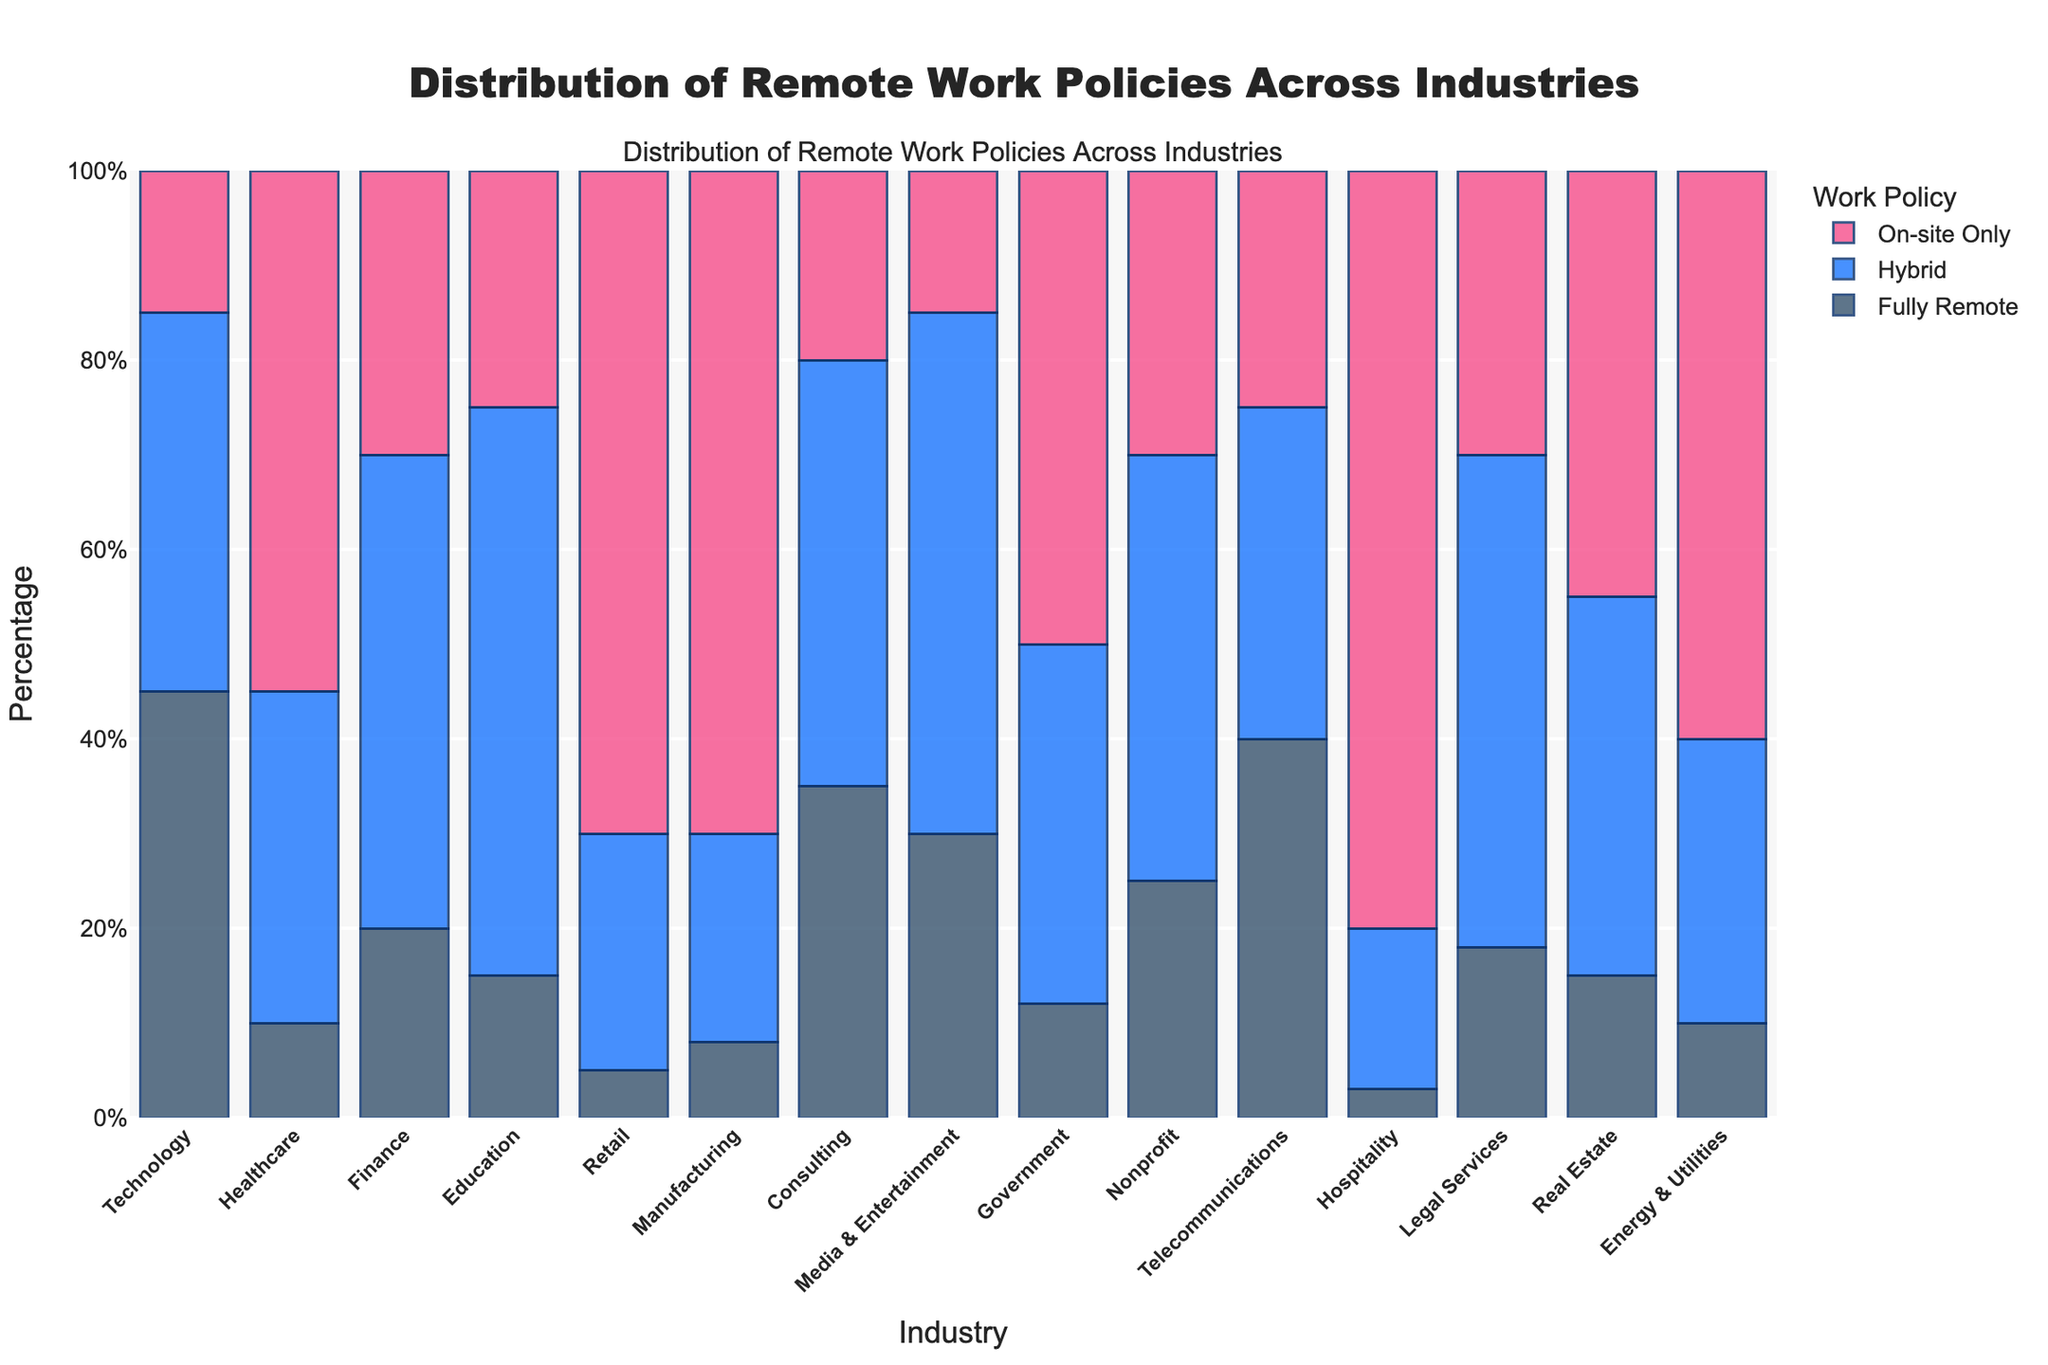What industry has the highest percentage of fully remote work? Look at the heights of the bars for "Fully Remote (%)" and identify the industry with the tallest bar in that category. Technology has the highest percentage, as its bar is the tallest.
Answer: Technology Which industry has a higher percentage of hybrid work, Finance or Healthcare? Compare the heights of the hybrid bars for Finance and Healthcare. The bar for Finance is taller.
Answer: Finance What is the sum of the percentages of fully remote and on-site only for the Retail industry? Add the percentages of Fully Remote (5%) and On-site Only (70%) for Retail: 5 + 70 = 75.
Answer: 75% Which industry has the lowest percentage of on-site only work? Identify the industry with the shortest bar in the "On-site Only (%)" category. Hospitality has the shortest bar.
Answer: Hospitality Is the percentage of hybrid work in Education higher than the sum of fully remote and on-site only in Manufacturing? Compare the percentage of hybrid work in Education (60%) with the sum of fully remote (8%) and on-site only (70%) in Manufacturing: 60 > 8 + 70 is false.
Answer: No What is the difference in the percentage of fully remote work between Technology and Education? Subtract the percentage of fully remote work in Education (15%) from Technology (45%): 45 - 15 = 30.
Answer: 30% How does the percentage of on-site only work in Legal Services compare to that in Government? Compare the heights of the on-site only bars for Legal Services (30%) and Government (50%). Government's bar is taller.
Answer: Less Which industry has an equal distribution of fully remote, hybrid, and on-site work such that one category doesn't significantly deviate from the others? Visually inspect the bars to find an industry where the three categories are most balanced. Consulting has fairly balanced bars.
Answer: Consulting In which industry are hybrid work policies more prevalent than both fully remote and on-site only combined? Check the height of hybrid bars and compare them with the sum of fully remote and on-site only bars in each industry. Education is the only industry where hybrid (60%) exceeds the sum of fully remote (15%) and on-site only (25%): 60 > 15 + 25.
Answer: Education 